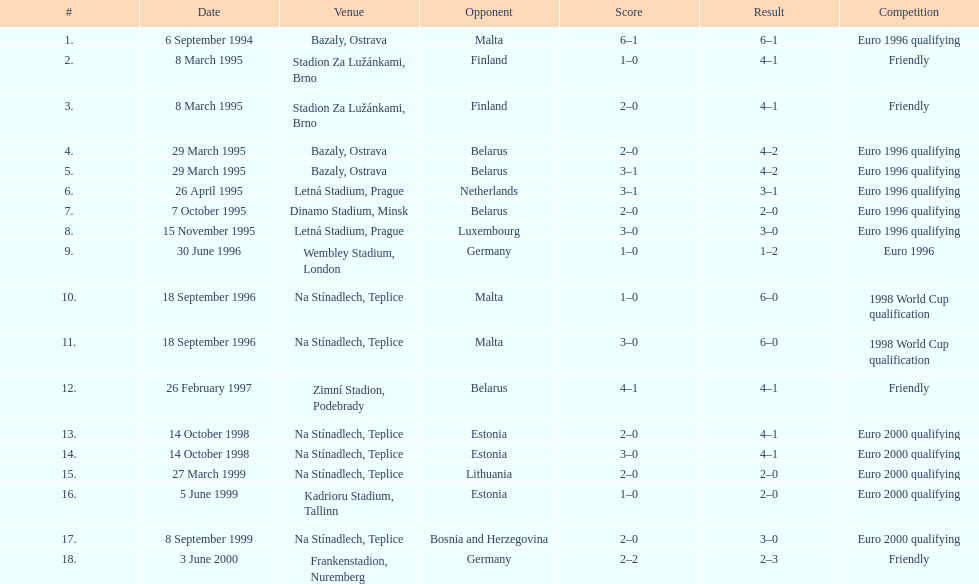Name the competitor with the lowest result compared to all other results. Germany. 